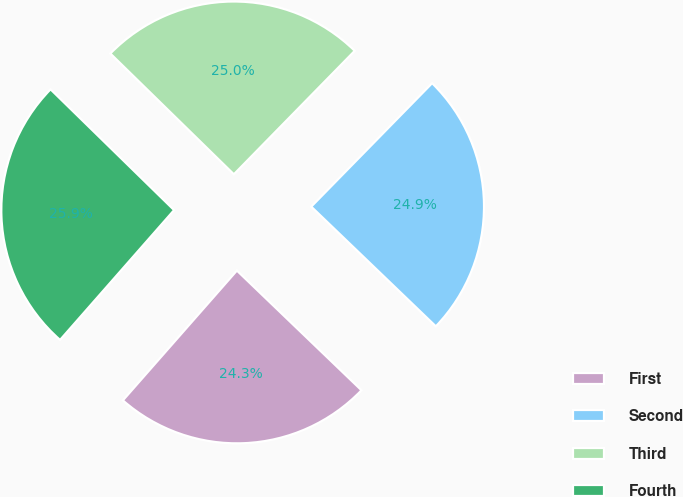Convert chart to OTSL. <chart><loc_0><loc_0><loc_500><loc_500><pie_chart><fcel>First<fcel>Second<fcel>Third<fcel>Fourth<nl><fcel>24.29%<fcel>24.85%<fcel>25.01%<fcel>25.85%<nl></chart> 